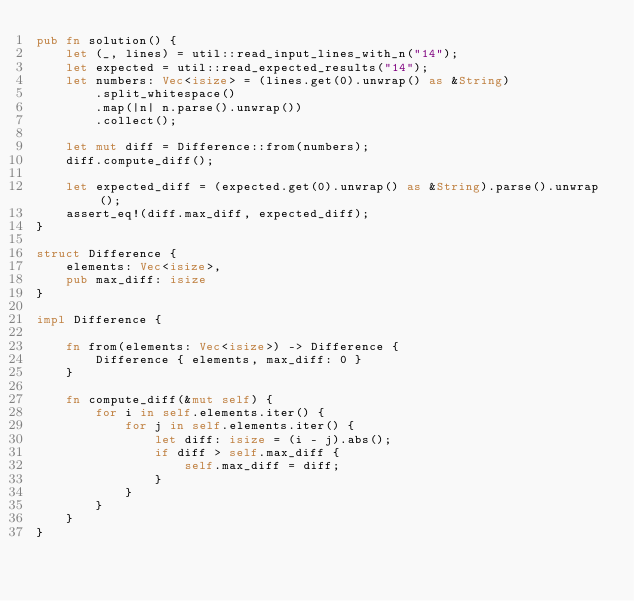Convert code to text. <code><loc_0><loc_0><loc_500><loc_500><_Rust_>pub fn solution() {
    let (_, lines) = util::read_input_lines_with_n("14");
    let expected = util::read_expected_results("14");
    let numbers: Vec<isize> = (lines.get(0).unwrap() as &String)
        .split_whitespace()
        .map(|n| n.parse().unwrap())
        .collect();

    let mut diff = Difference::from(numbers);
    diff.compute_diff();

    let expected_diff = (expected.get(0).unwrap() as &String).parse().unwrap();
    assert_eq!(diff.max_diff, expected_diff);
}

struct Difference {
    elements: Vec<isize>,
    pub max_diff: isize
}

impl Difference {

    fn from(elements: Vec<isize>) -> Difference {
        Difference { elements, max_diff: 0 }
    }

    fn compute_diff(&mut self) {
        for i in self.elements.iter() {
            for j in self.elements.iter() {
                let diff: isize = (i - j).abs();
                if diff > self.max_diff {
                    self.max_diff = diff;
                }
            }
        }
    }
}</code> 